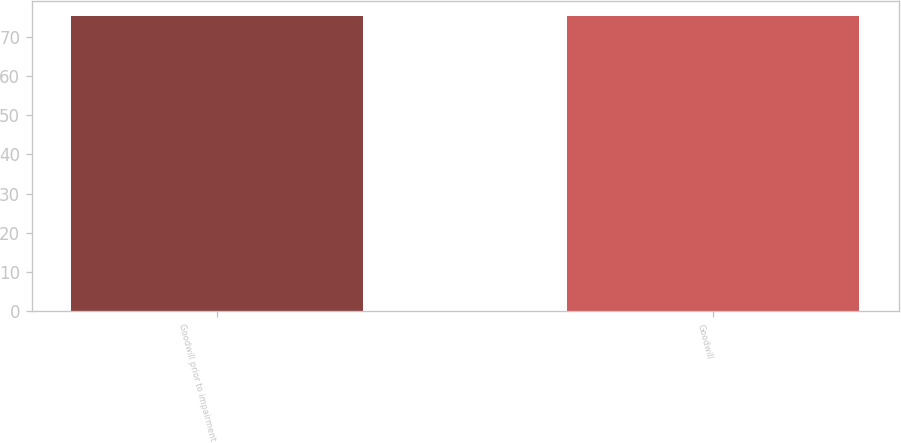Convert chart. <chart><loc_0><loc_0><loc_500><loc_500><bar_chart><fcel>Goodwill prior to impairment<fcel>Goodwill<nl><fcel>75.3<fcel>75.4<nl></chart> 